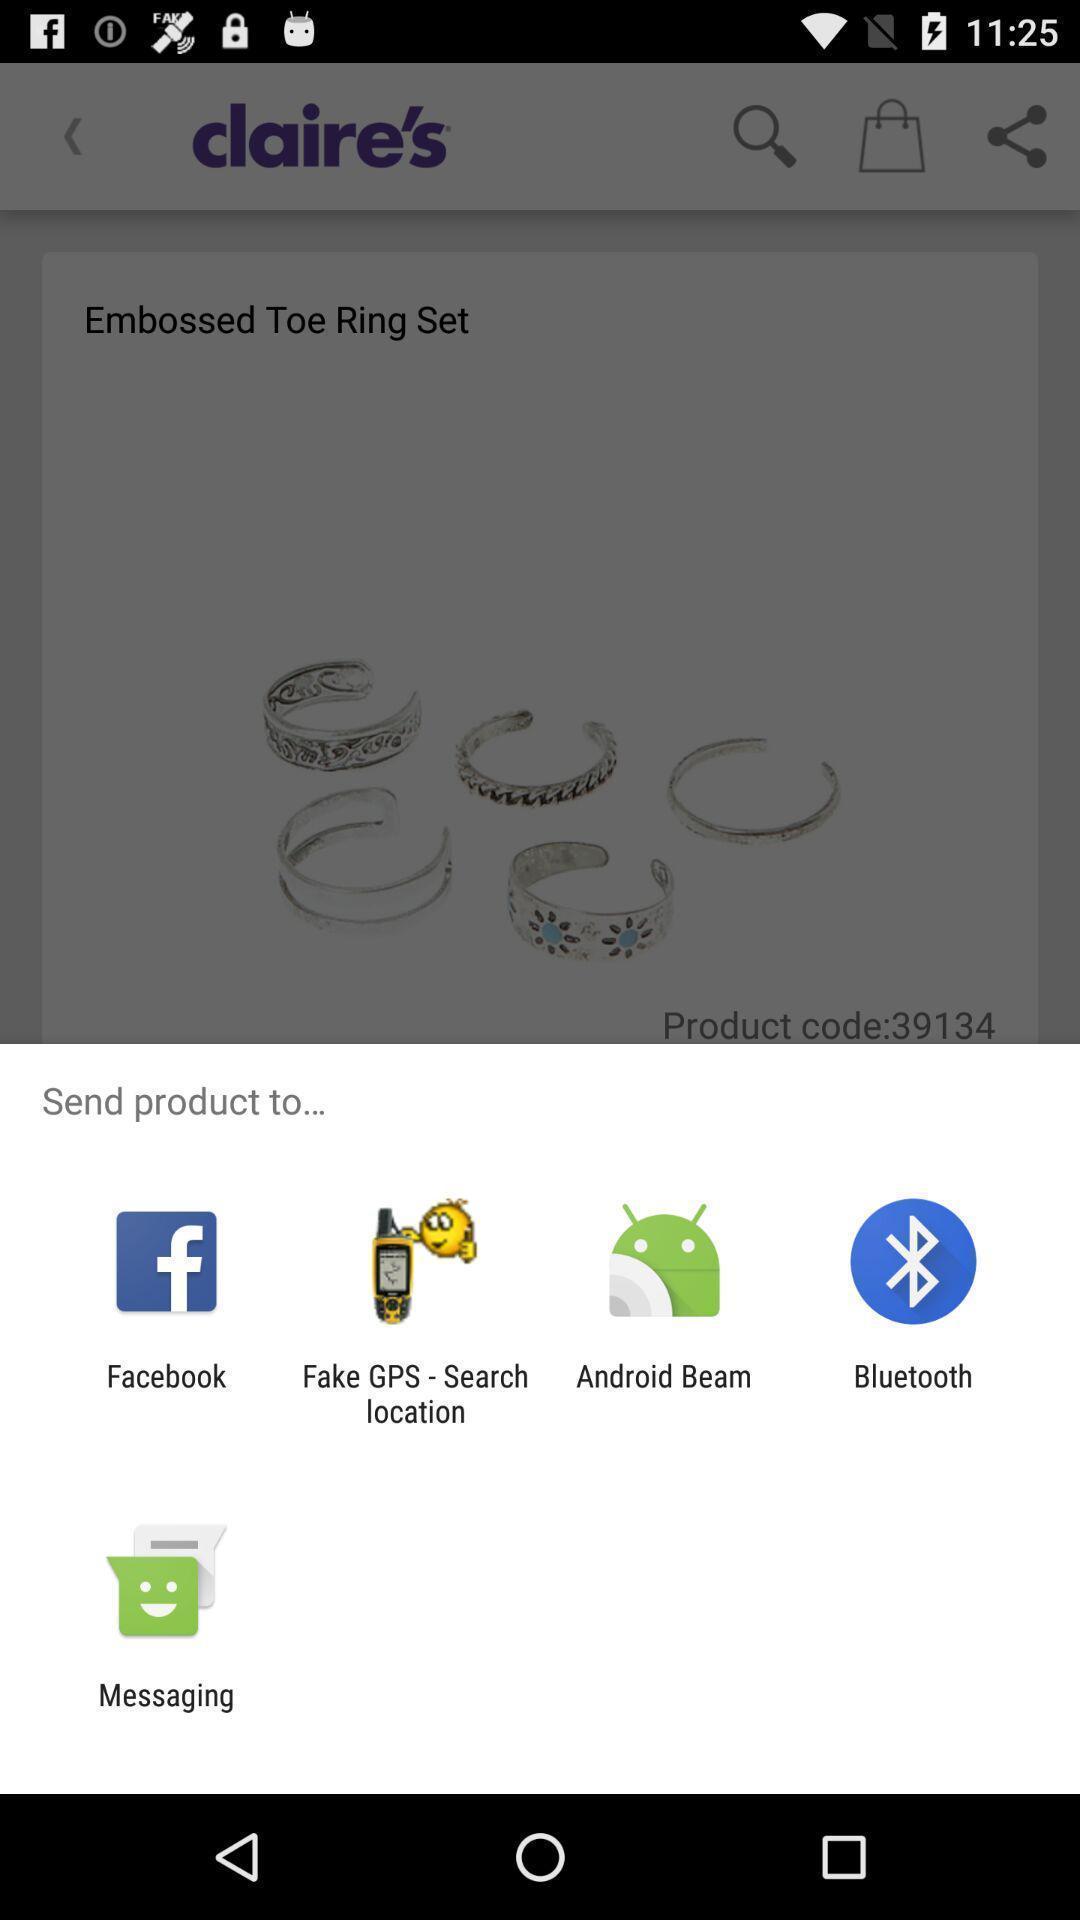Give me a narrative description of this picture. Pop-up shows to send products to multiple other apps. 